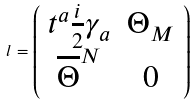Convert formula to latex. <formula><loc_0><loc_0><loc_500><loc_500>l = \left ( \begin{array} { c c } t ^ { a } \frac { i } { 2 } \gamma _ { a } & \Theta _ { M } \\ \overline { \Theta } ^ { N } & 0 \end{array} \right )</formula> 